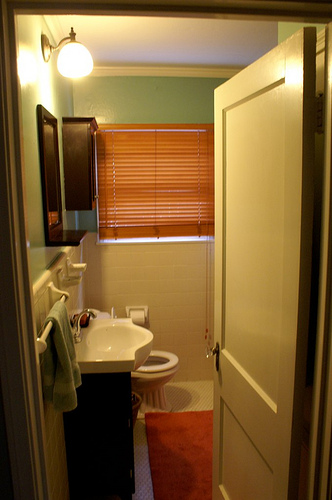Given this image, can you imagine a day in the life of someone who uses this bathroom? A day in the life of someone who uses this bathroom likely starts with a refreshing morning routine. They might begin by brushing their teeth and washing their face at the sink, enjoying the ample natural light streaming through the window. After their morning rituals, they grab a towel from the rack and prepare to start their day. Throughout the day, the bathroom serves as a quick retreat for freshening up, and by the evening, the user enjoys a comforting nighttime ritual involving a warm glow from the bathroom lights, creating a serene end to their day. Create a short scenario where this bathroom plays a crucial role. One morning, the bathroom becomes a crucial preparation area for someone getting ready for an important job interview. The ambiance helps them stay calm and collected as they meticulously clean and groom themselves. The well-organized space allows quick access to their grooming tools, ensuring that they leave the house feeling confident and well-prepared for their big day. 